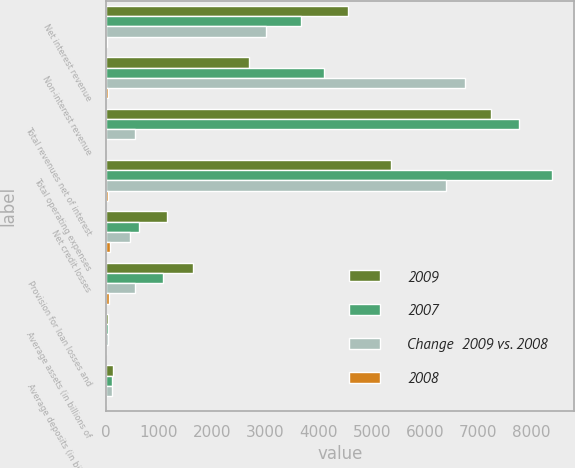Convert chart to OTSL. <chart><loc_0><loc_0><loc_500><loc_500><stacked_bar_chart><ecel><fcel>Net interest revenue<fcel>Non-interest revenue<fcel>Total revenues net of interest<fcel>Total operating expenses<fcel>Net credit losses<fcel>Provision for loan losses and<fcel>Average assets (in billions of<fcel>Average deposits (in billions<nl><fcel>2009<fcel>4559<fcel>2687<fcel>7246<fcel>5359<fcel>1151<fcel>1645<fcel>34<fcel>137<nl><fcel>2007<fcel>3662<fcel>4102<fcel>7764<fcel>8388<fcel>615<fcel>1083<fcel>36<fcel>123<nl><fcel>Change  2009 vs. 2008<fcel>3019<fcel>6754<fcel>543<fcel>6401<fcel>450<fcel>543<fcel>39<fcel>120<nl><fcel>2008<fcel>24<fcel>34<fcel>7<fcel>36<fcel>87<fcel>52<fcel>6<fcel>11<nl></chart> 